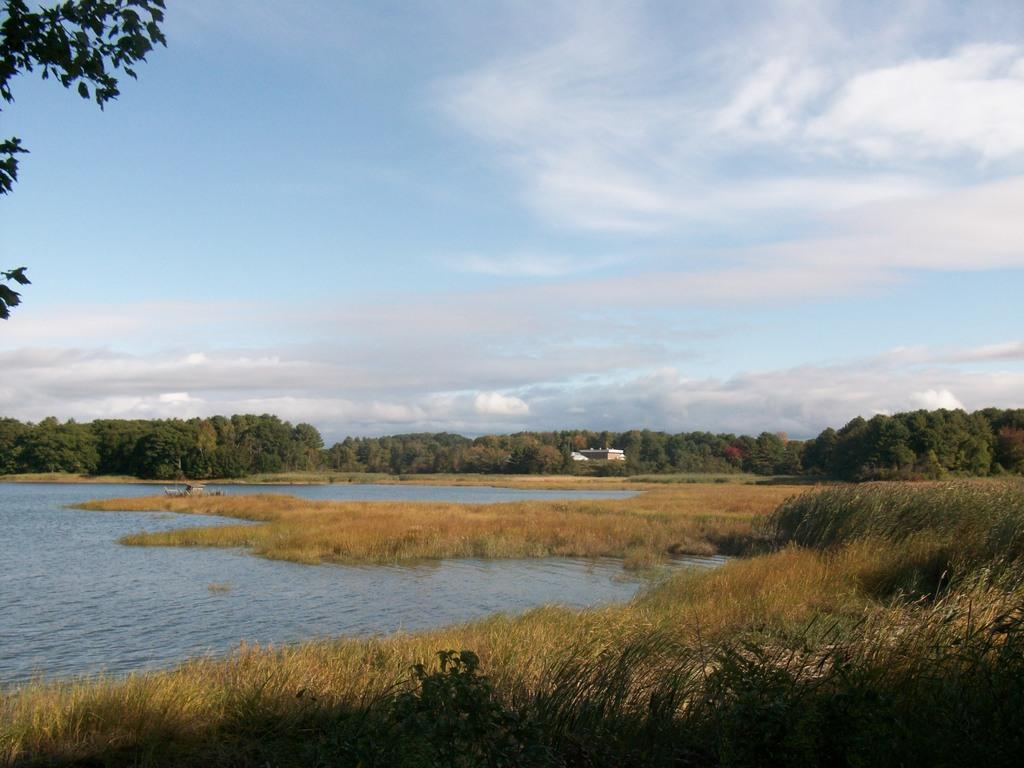What type of vegetation can be seen in the image? There is grass, plants, and trees visible in the image. What is the object in the image? The object in the image is not specified, but it could be a bench, a statue, or another outdoor feature. What is visible in the sky in the image? The sky is visible in the image, and there are clouds present. Is there any water visible in the image? Yes, there is water visible in the image. What can be seen on the left side of the image? There are leaves on the left side of the image. What type of pocket can be seen in the image? There is no pocket present in the image. What is the destination of the journey depicted in the image? There is no journey depicted in the image; it is a static scene of outdoor vegetation and water. 